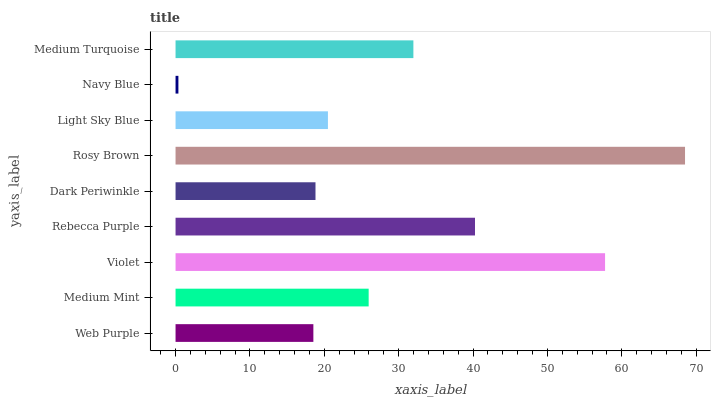Is Navy Blue the minimum?
Answer yes or no. Yes. Is Rosy Brown the maximum?
Answer yes or no. Yes. Is Medium Mint the minimum?
Answer yes or no. No. Is Medium Mint the maximum?
Answer yes or no. No. Is Medium Mint greater than Web Purple?
Answer yes or no. Yes. Is Web Purple less than Medium Mint?
Answer yes or no. Yes. Is Web Purple greater than Medium Mint?
Answer yes or no. No. Is Medium Mint less than Web Purple?
Answer yes or no. No. Is Medium Mint the high median?
Answer yes or no. Yes. Is Medium Mint the low median?
Answer yes or no. Yes. Is Violet the high median?
Answer yes or no. No. Is Rebecca Purple the low median?
Answer yes or no. No. 